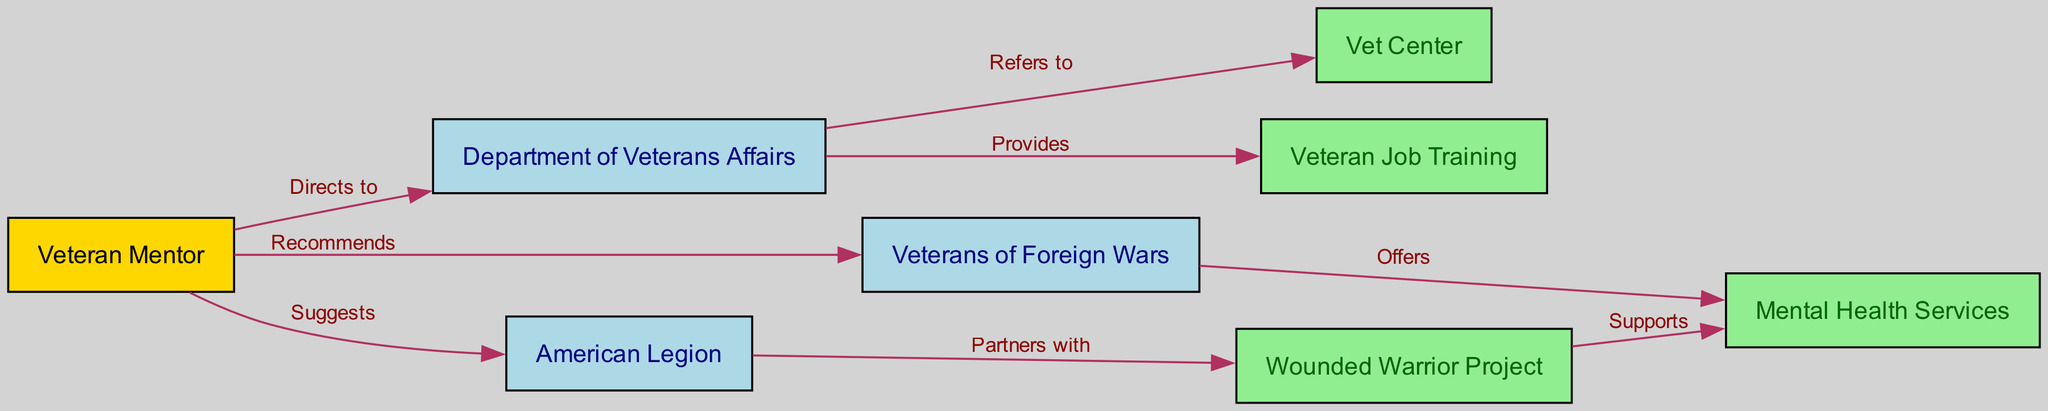What is the main node identified in the diagram? The main node, representing the individual offering support, is labeled "Veteran Mentor".
Answer: Veteran Mentor How many organizations are connected to the Department of Veterans Affairs? The Department of Veterans Affairs connects directly to two organizations: Vet Center and Veteran Job Training.
Answer: 2 Which organization does the Veteran Mentor recommend? The Veteran Mentor suggests the Veterans of Foreign Wars as a source of support.
Answer: Veterans of Foreign Wars What kind of support does the Wounded Warrior Project provide? The Wounded Warrior Project supports mental health services, indicating a focus on veterans' psychological well-being.
Answer: Supports Which node is directly connected to the American Legion? The American Legion partners with the Wounded Warrior Project, creating a functional link between their services.
Answer: Wounded Warrior Project How many edges are there total in the diagram? By counting the relationship pathways connecting the nodes, we find there are eight edges, each representing a different interaction or referral.
Answer: 8 If a veteran seeks job training, which organization should they be directed to? The Department of Veterans Affairs provides the connection to Veteran Job Training as a key resource for assisting veterans in this regard.
Answer: Veteran Job Training What does the Veterans of Foreign Wars offer? The Veterans of Foreign Wars provides access to mental health services, highlighting their role in veteran care.
Answer: Offers What is the color of the Veteran Mentor node? The Veteran Mentor node is distinguished by a gold color, signifying its central role in the diagram.
Answer: Gold 